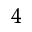<formula> <loc_0><loc_0><loc_500><loc_500>^ { 4 }</formula> 